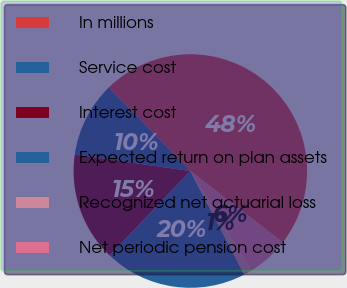<chart> <loc_0><loc_0><loc_500><loc_500><pie_chart><fcel>In millions<fcel>Service cost<fcel>Interest cost<fcel>Expected return on plan assets<fcel>Recognized net actuarial loss<fcel>Net periodic pension cost<nl><fcel>47.77%<fcel>10.45%<fcel>15.11%<fcel>19.78%<fcel>1.12%<fcel>5.78%<nl></chart> 